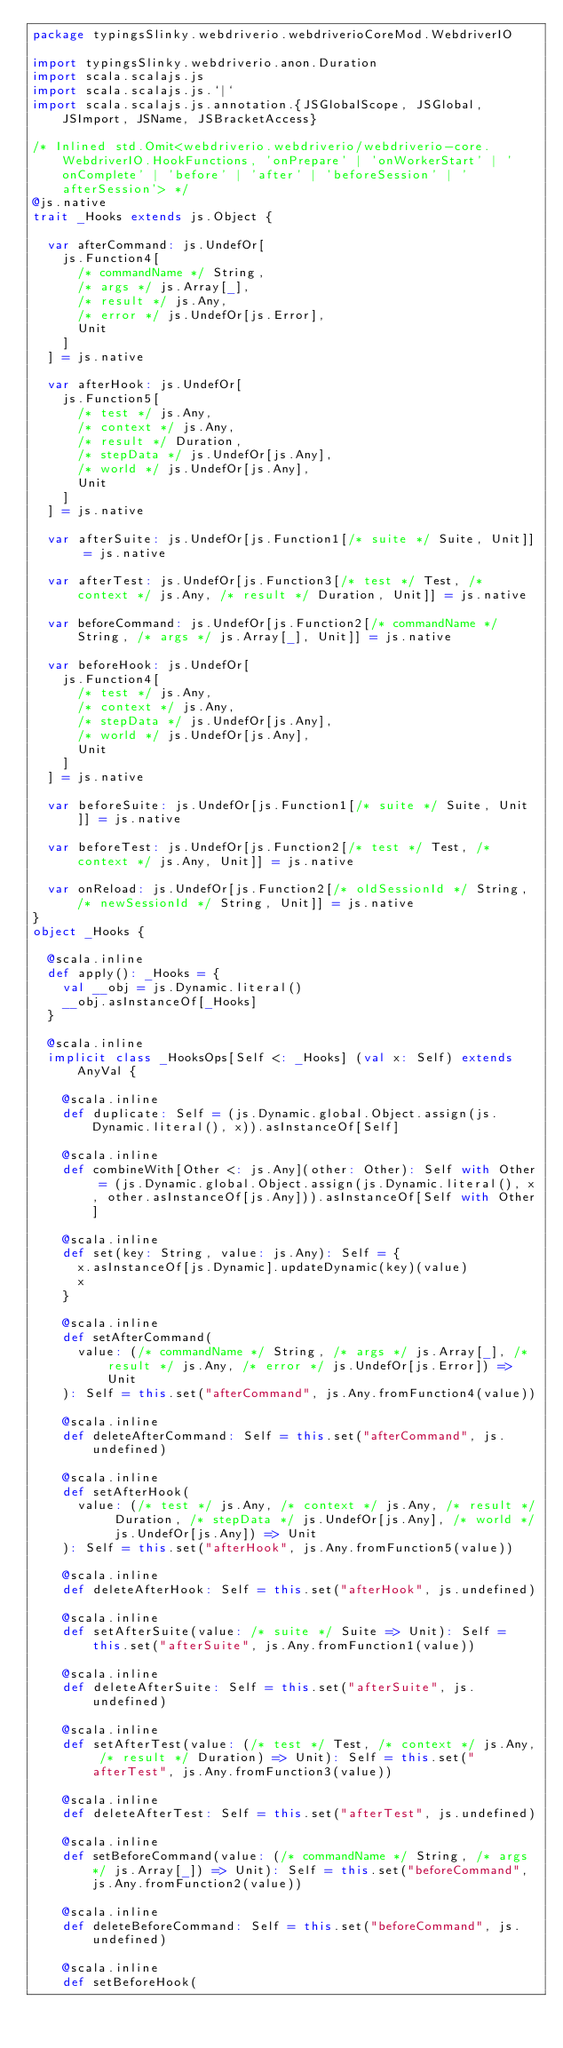Convert code to text. <code><loc_0><loc_0><loc_500><loc_500><_Scala_>package typingsSlinky.webdriverio.webdriverioCoreMod.WebdriverIO

import typingsSlinky.webdriverio.anon.Duration
import scala.scalajs.js
import scala.scalajs.js.`|`
import scala.scalajs.js.annotation.{JSGlobalScope, JSGlobal, JSImport, JSName, JSBracketAccess}

/* Inlined std.Omit<webdriverio.webdriverio/webdriverio-core.WebdriverIO.HookFunctions, 'onPrepare' | 'onWorkerStart' | 'onComplete' | 'before' | 'after' | 'beforeSession' | 'afterSession'> */
@js.native
trait _Hooks extends js.Object {
  
  var afterCommand: js.UndefOr[
    js.Function4[
      /* commandName */ String, 
      /* args */ js.Array[_], 
      /* result */ js.Any, 
      /* error */ js.UndefOr[js.Error], 
      Unit
    ]
  ] = js.native
  
  var afterHook: js.UndefOr[
    js.Function5[
      /* test */ js.Any, 
      /* context */ js.Any, 
      /* result */ Duration, 
      /* stepData */ js.UndefOr[js.Any], 
      /* world */ js.UndefOr[js.Any], 
      Unit
    ]
  ] = js.native
  
  var afterSuite: js.UndefOr[js.Function1[/* suite */ Suite, Unit]] = js.native
  
  var afterTest: js.UndefOr[js.Function3[/* test */ Test, /* context */ js.Any, /* result */ Duration, Unit]] = js.native
  
  var beforeCommand: js.UndefOr[js.Function2[/* commandName */ String, /* args */ js.Array[_], Unit]] = js.native
  
  var beforeHook: js.UndefOr[
    js.Function4[
      /* test */ js.Any, 
      /* context */ js.Any, 
      /* stepData */ js.UndefOr[js.Any], 
      /* world */ js.UndefOr[js.Any], 
      Unit
    ]
  ] = js.native
  
  var beforeSuite: js.UndefOr[js.Function1[/* suite */ Suite, Unit]] = js.native
  
  var beforeTest: js.UndefOr[js.Function2[/* test */ Test, /* context */ js.Any, Unit]] = js.native
  
  var onReload: js.UndefOr[js.Function2[/* oldSessionId */ String, /* newSessionId */ String, Unit]] = js.native
}
object _Hooks {
  
  @scala.inline
  def apply(): _Hooks = {
    val __obj = js.Dynamic.literal()
    __obj.asInstanceOf[_Hooks]
  }
  
  @scala.inline
  implicit class _HooksOps[Self <: _Hooks] (val x: Self) extends AnyVal {
    
    @scala.inline
    def duplicate: Self = (js.Dynamic.global.Object.assign(js.Dynamic.literal(), x)).asInstanceOf[Self]
    
    @scala.inline
    def combineWith[Other <: js.Any](other: Other): Self with Other = (js.Dynamic.global.Object.assign(js.Dynamic.literal(), x, other.asInstanceOf[js.Any])).asInstanceOf[Self with Other]
    
    @scala.inline
    def set(key: String, value: js.Any): Self = {
      x.asInstanceOf[js.Dynamic].updateDynamic(key)(value)
      x
    }
    
    @scala.inline
    def setAfterCommand(
      value: (/* commandName */ String, /* args */ js.Array[_], /* result */ js.Any, /* error */ js.UndefOr[js.Error]) => Unit
    ): Self = this.set("afterCommand", js.Any.fromFunction4(value))
    
    @scala.inline
    def deleteAfterCommand: Self = this.set("afterCommand", js.undefined)
    
    @scala.inline
    def setAfterHook(
      value: (/* test */ js.Any, /* context */ js.Any, /* result */ Duration, /* stepData */ js.UndefOr[js.Any], /* world */ js.UndefOr[js.Any]) => Unit
    ): Self = this.set("afterHook", js.Any.fromFunction5(value))
    
    @scala.inline
    def deleteAfterHook: Self = this.set("afterHook", js.undefined)
    
    @scala.inline
    def setAfterSuite(value: /* suite */ Suite => Unit): Self = this.set("afterSuite", js.Any.fromFunction1(value))
    
    @scala.inline
    def deleteAfterSuite: Self = this.set("afterSuite", js.undefined)
    
    @scala.inline
    def setAfterTest(value: (/* test */ Test, /* context */ js.Any, /* result */ Duration) => Unit): Self = this.set("afterTest", js.Any.fromFunction3(value))
    
    @scala.inline
    def deleteAfterTest: Self = this.set("afterTest", js.undefined)
    
    @scala.inline
    def setBeforeCommand(value: (/* commandName */ String, /* args */ js.Array[_]) => Unit): Self = this.set("beforeCommand", js.Any.fromFunction2(value))
    
    @scala.inline
    def deleteBeforeCommand: Self = this.set("beforeCommand", js.undefined)
    
    @scala.inline
    def setBeforeHook(</code> 